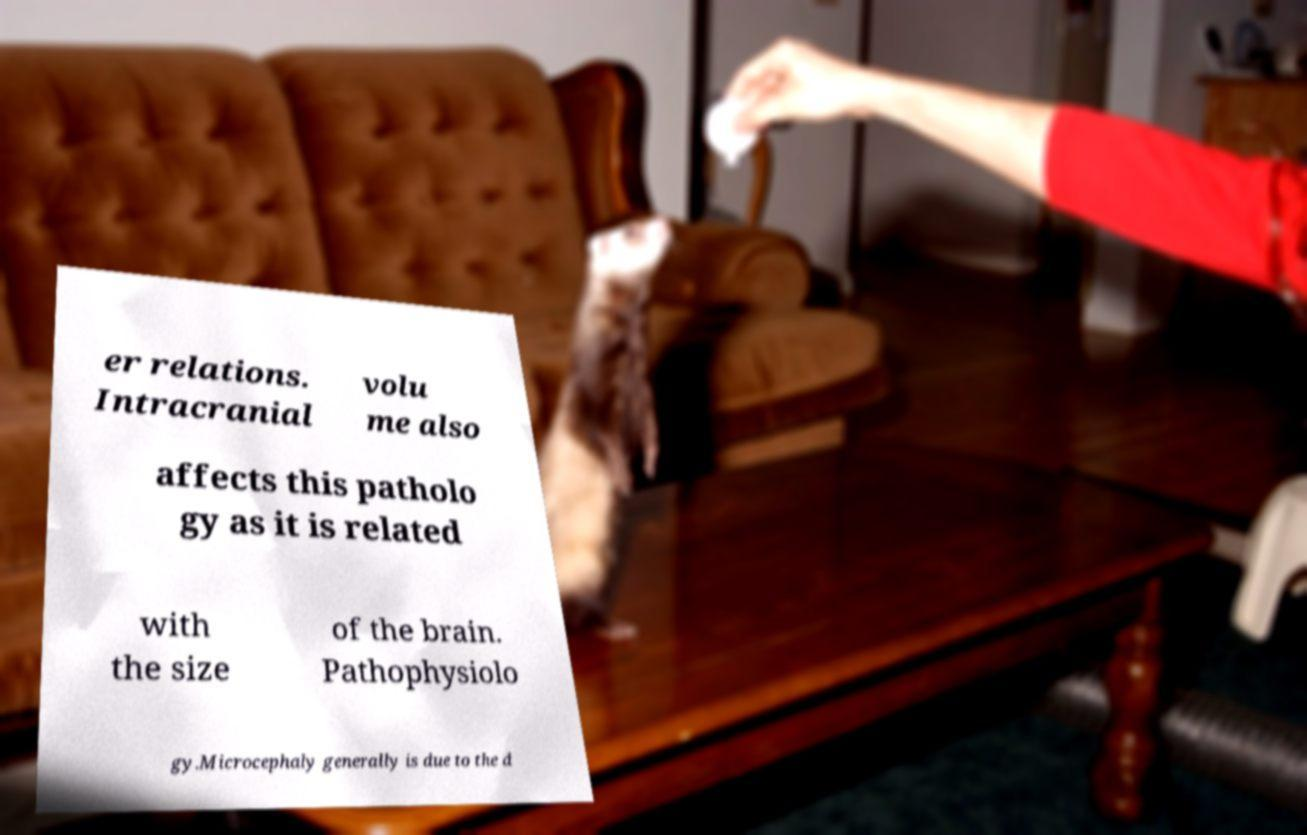Please read and relay the text visible in this image. What does it say? er relations. Intracranial volu me also affects this patholo gy as it is related with the size of the brain. Pathophysiolo gy.Microcephaly generally is due to the d 